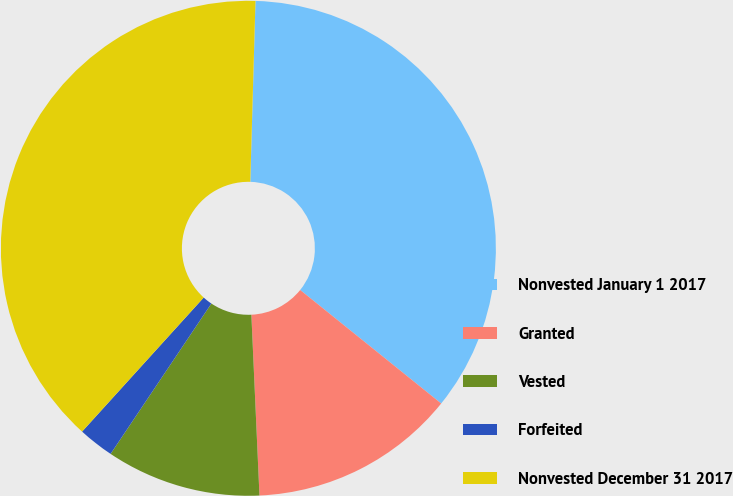<chart> <loc_0><loc_0><loc_500><loc_500><pie_chart><fcel>Nonvested January 1 2017<fcel>Granted<fcel>Vested<fcel>Forfeited<fcel>Nonvested December 31 2017<nl><fcel>35.33%<fcel>13.5%<fcel>10.11%<fcel>2.33%<fcel>38.73%<nl></chart> 